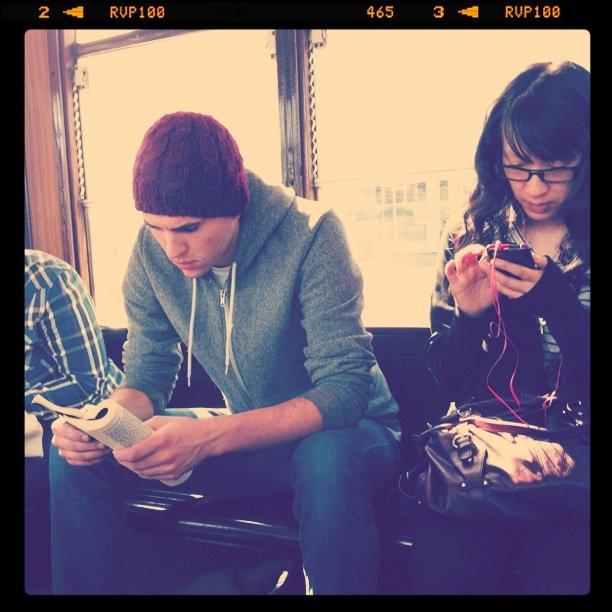Does the woman have her hair tied back?
Keep it brief. No. What is the man wearing on his head?
Be succinct. Beanie. What is the man in blue hoodie doing?
Concise answer only. Reading. Are they riding public transportation?
Short answer required. Yes. How many men are wearing glasses?
Give a very brief answer. 0. How many people are in the college?
Concise answer only. 3. How many people are wearing hats?
Keep it brief. 1. 